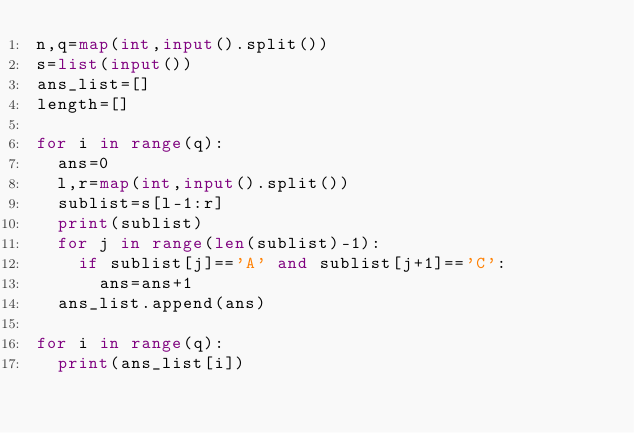Convert code to text. <code><loc_0><loc_0><loc_500><loc_500><_Python_>n,q=map(int,input().split())
s=list(input())
ans_list=[]
length=[]

for i in range(q):
  ans=0
  l,r=map(int,input().split())
  sublist=s[l-1:r]
  print(sublist)
  for j in range(len(sublist)-1):
    if sublist[j]=='A' and sublist[j+1]=='C':
      ans=ans+1
  ans_list.append(ans)
  
for i in range(q):
  print(ans_list[i])</code> 